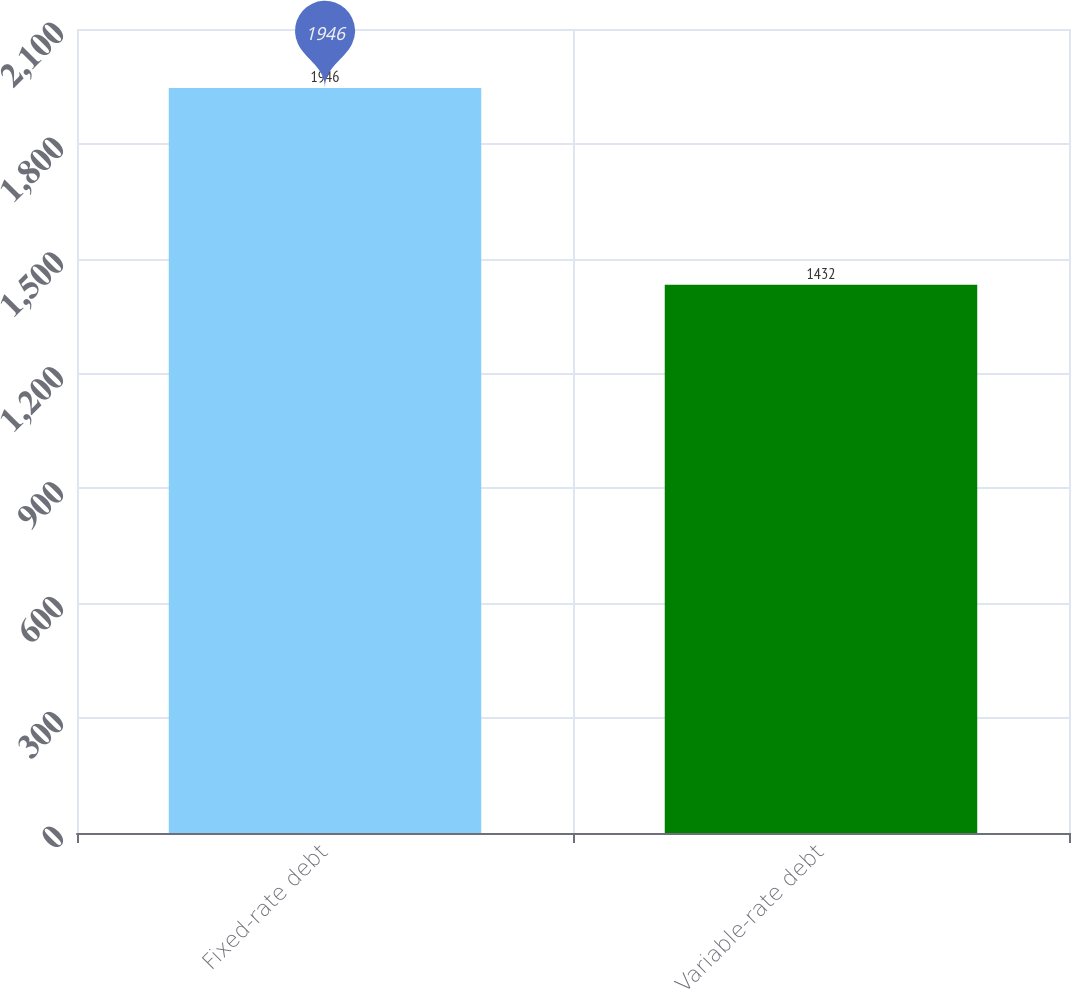Convert chart. <chart><loc_0><loc_0><loc_500><loc_500><bar_chart><fcel>Fixed-rate debt<fcel>Variable-rate debt<nl><fcel>1946<fcel>1432<nl></chart> 